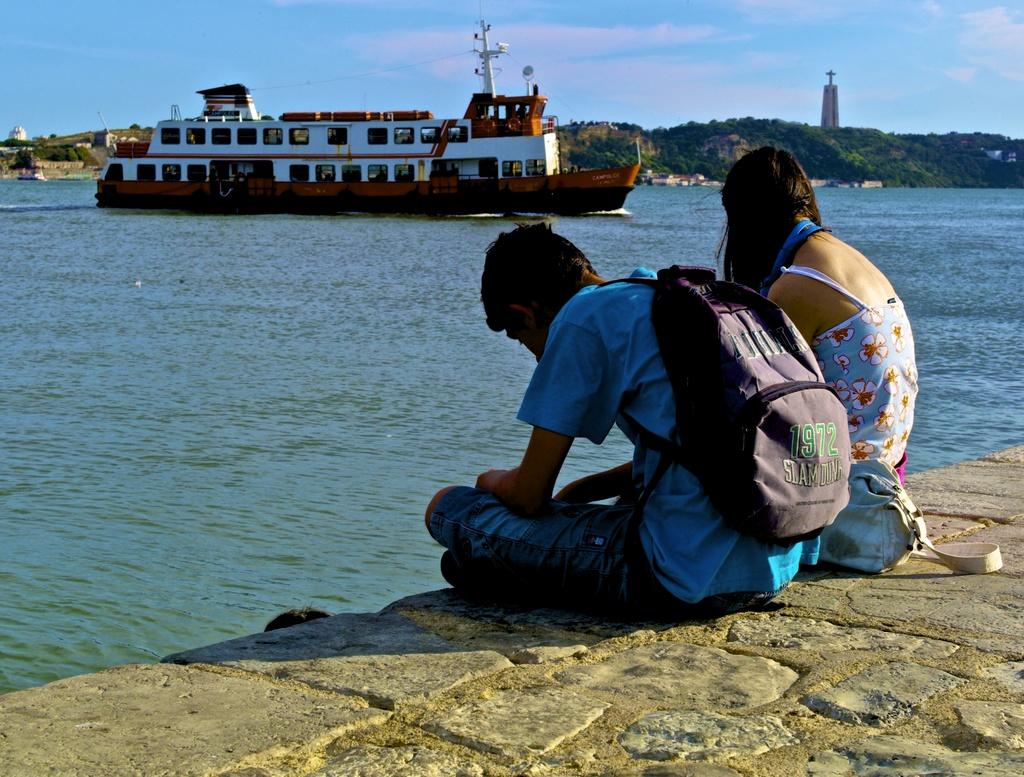How many people are sitting in the image? There are two people sitting in the image. What is one person wearing? One person is wearing a bag. What can be seen in the background of the image? There is a ship visible in the image. What is the primary element in the image? There is water in the image. Who won the competition between the two people in the image? There is no competition between the two people in the image. What type of pen is the person holding in the image? There is no pen present in the image. 